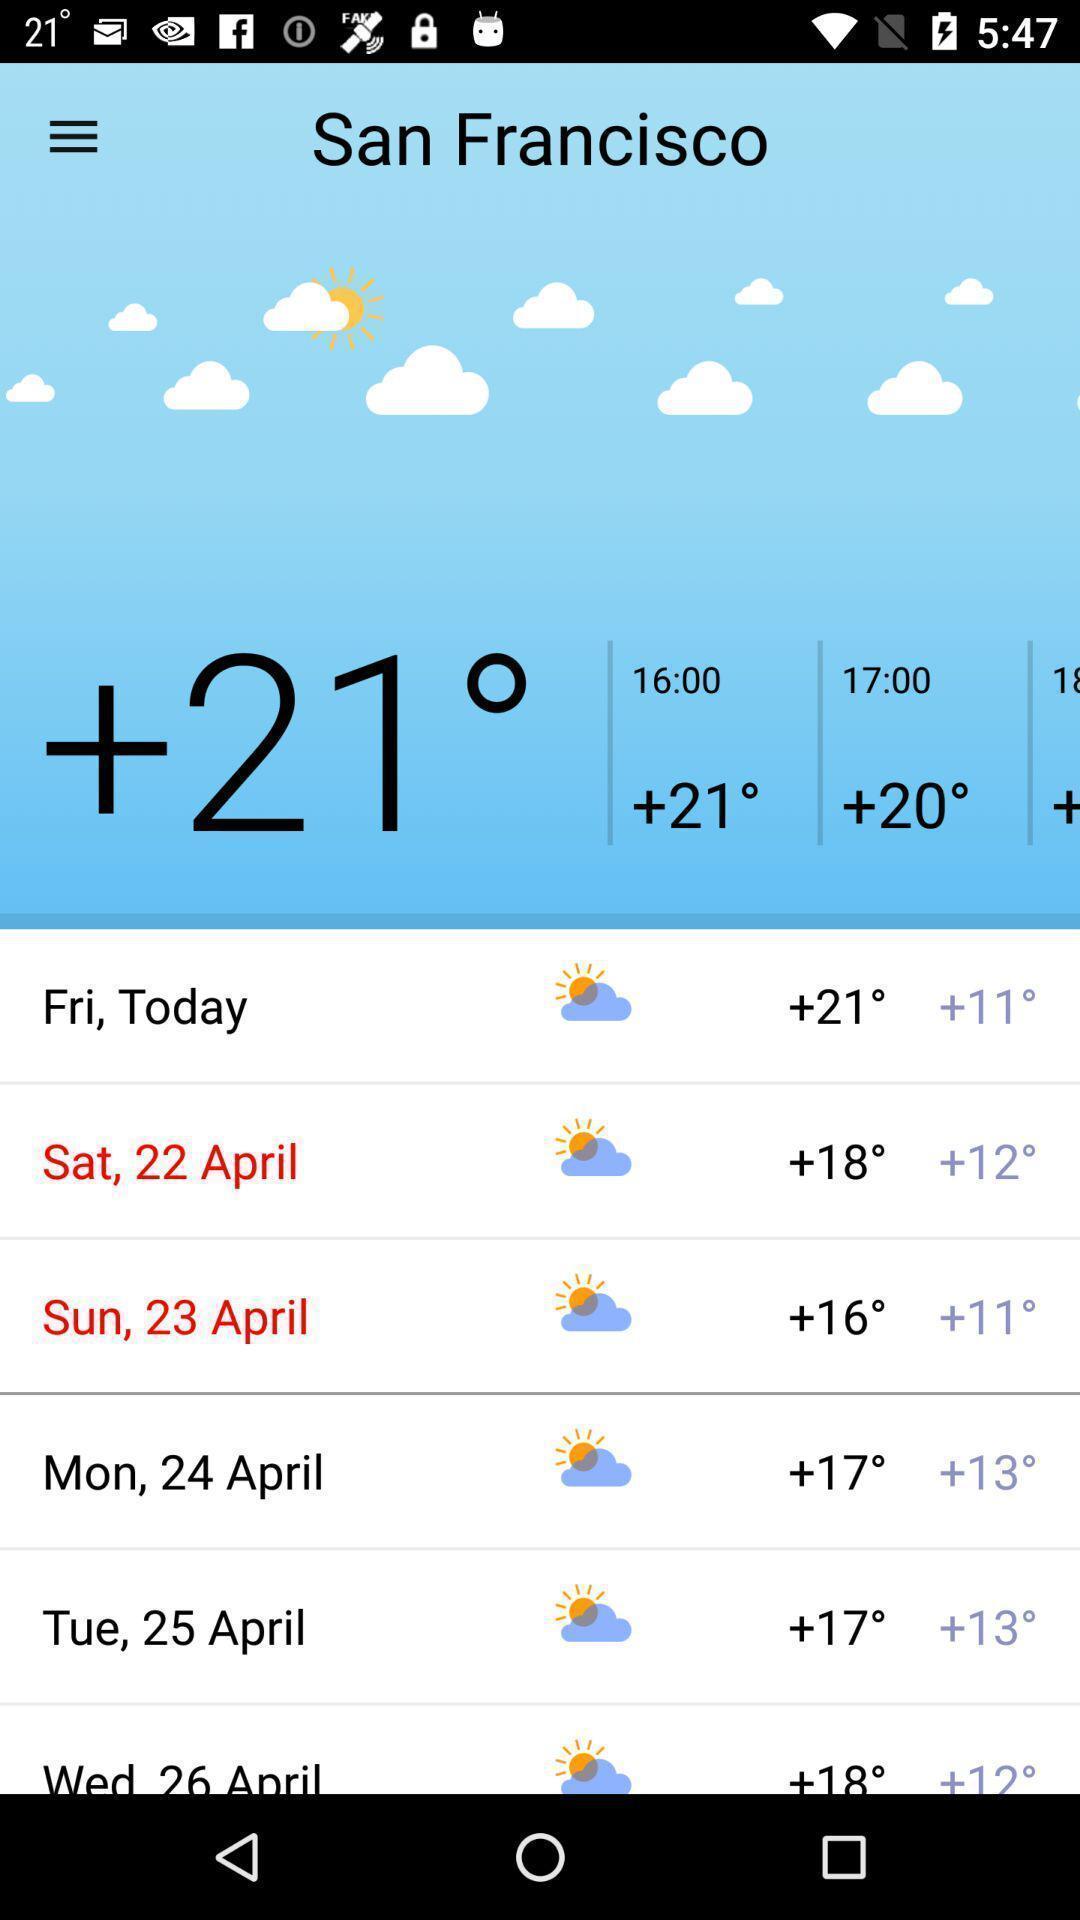Provide a detailed account of this screenshot. Weather forecasting for a location in weather forecasting app. 